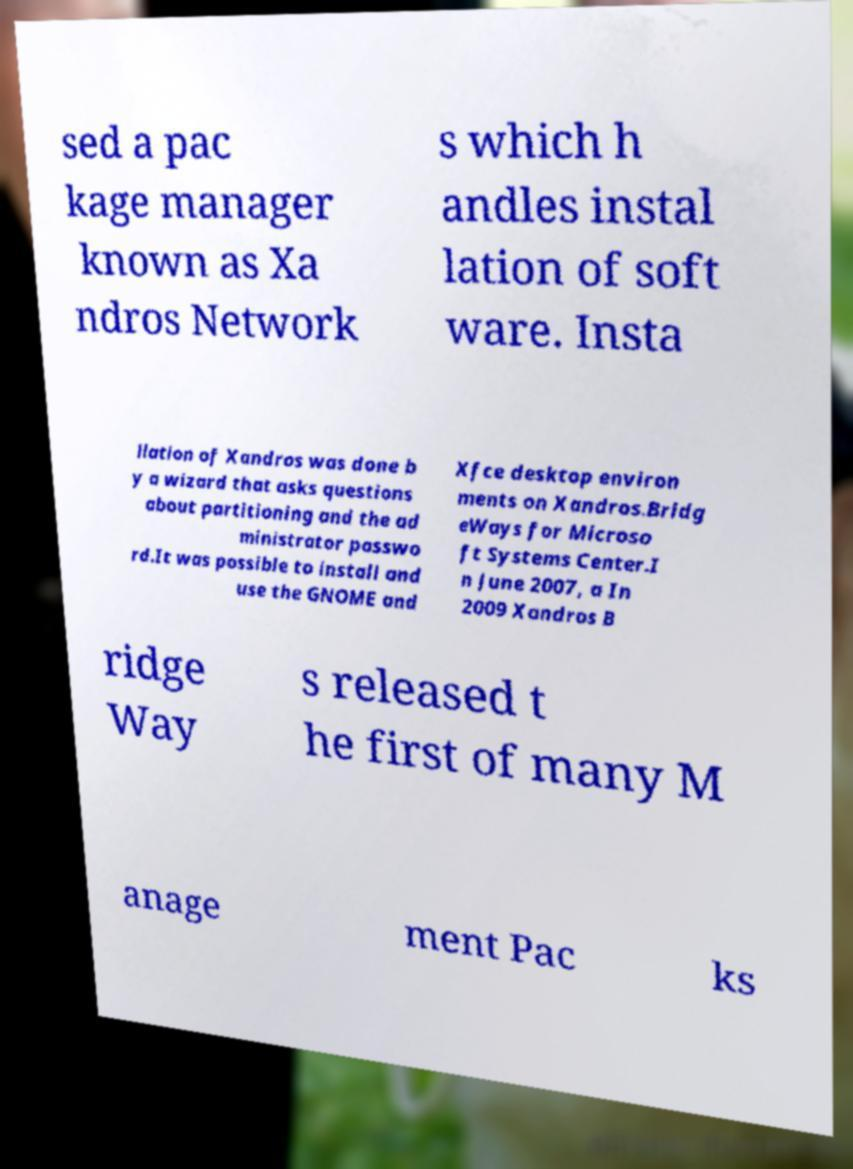Could you extract and type out the text from this image? sed a pac kage manager known as Xa ndros Network s which h andles instal lation of soft ware. Insta llation of Xandros was done b y a wizard that asks questions about partitioning and the ad ministrator passwo rd.It was possible to install and use the GNOME and Xfce desktop environ ments on Xandros.Bridg eWays for Microso ft Systems Center.I n June 2007, a In 2009 Xandros B ridge Way s released t he first of many M anage ment Pac ks 